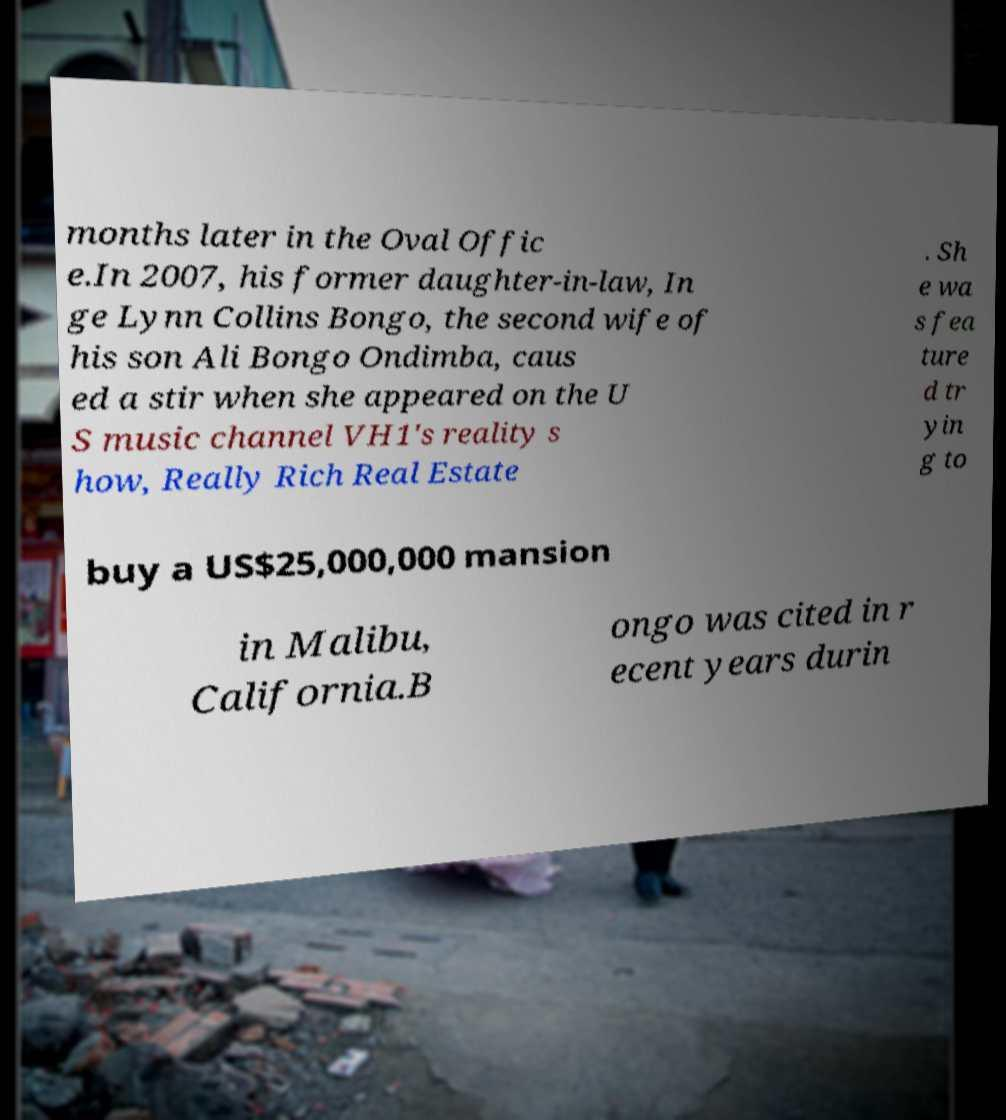Could you extract and type out the text from this image? months later in the Oval Offic e.In 2007, his former daughter-in-law, In ge Lynn Collins Bongo, the second wife of his son Ali Bongo Ondimba, caus ed a stir when she appeared on the U S music channel VH1's reality s how, Really Rich Real Estate . Sh e wa s fea ture d tr yin g to buy a US$25,000,000 mansion in Malibu, California.B ongo was cited in r ecent years durin 